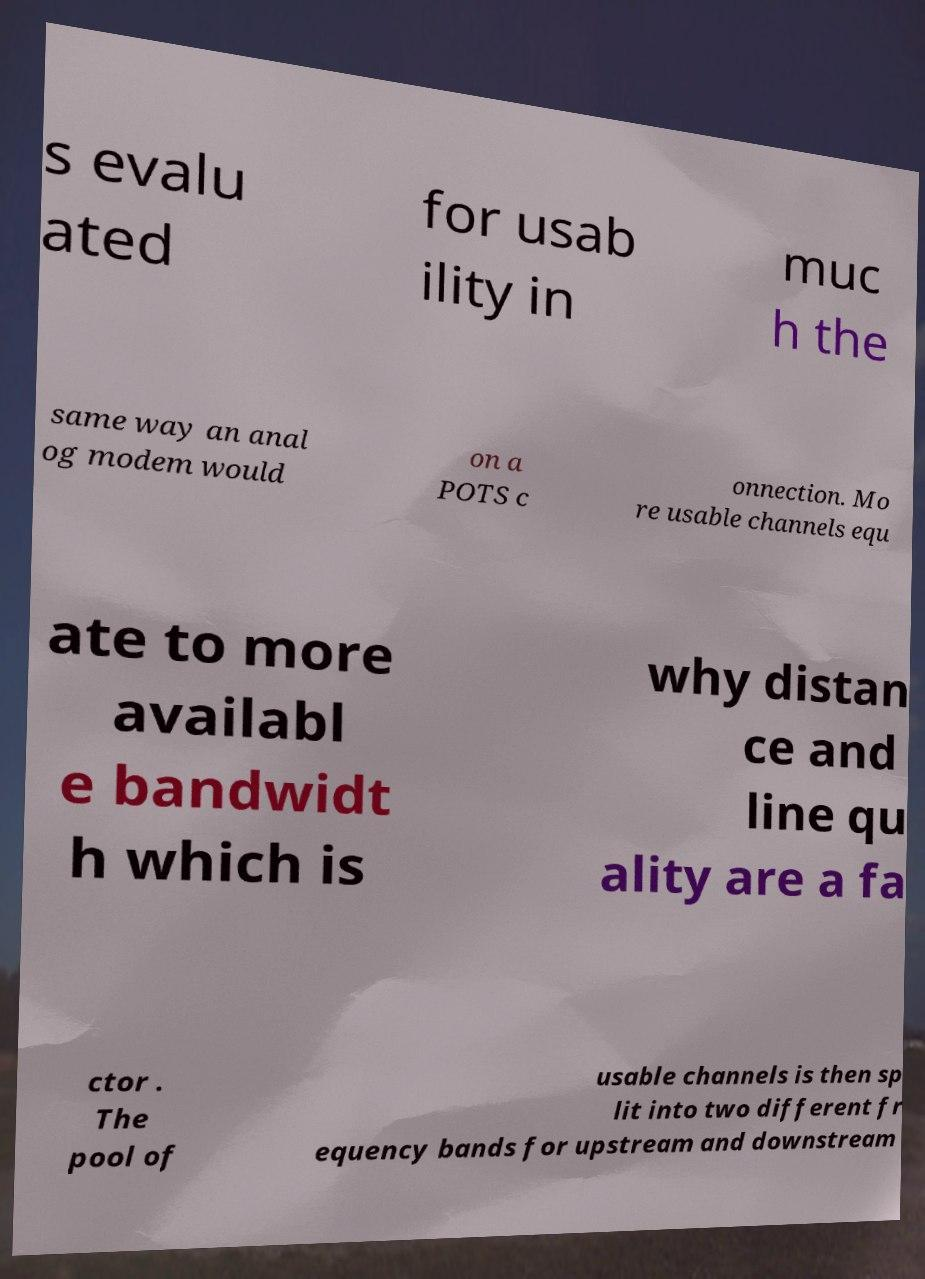For documentation purposes, I need the text within this image transcribed. Could you provide that? s evalu ated for usab ility in muc h the same way an anal og modem would on a POTS c onnection. Mo re usable channels equ ate to more availabl e bandwidt h which is why distan ce and line qu ality are a fa ctor . The pool of usable channels is then sp lit into two different fr equency bands for upstream and downstream 